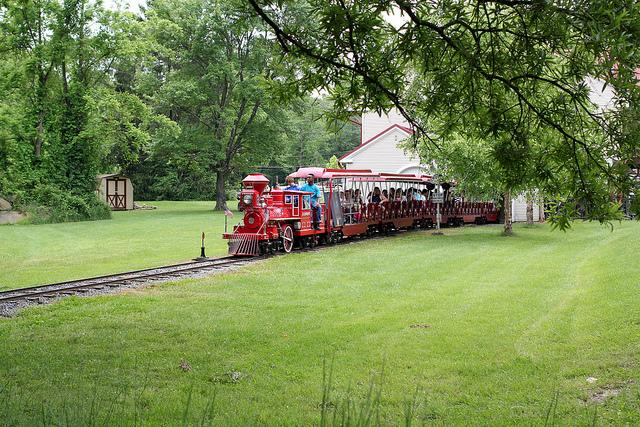What is the small brown structure in the back left of the yard? shed 